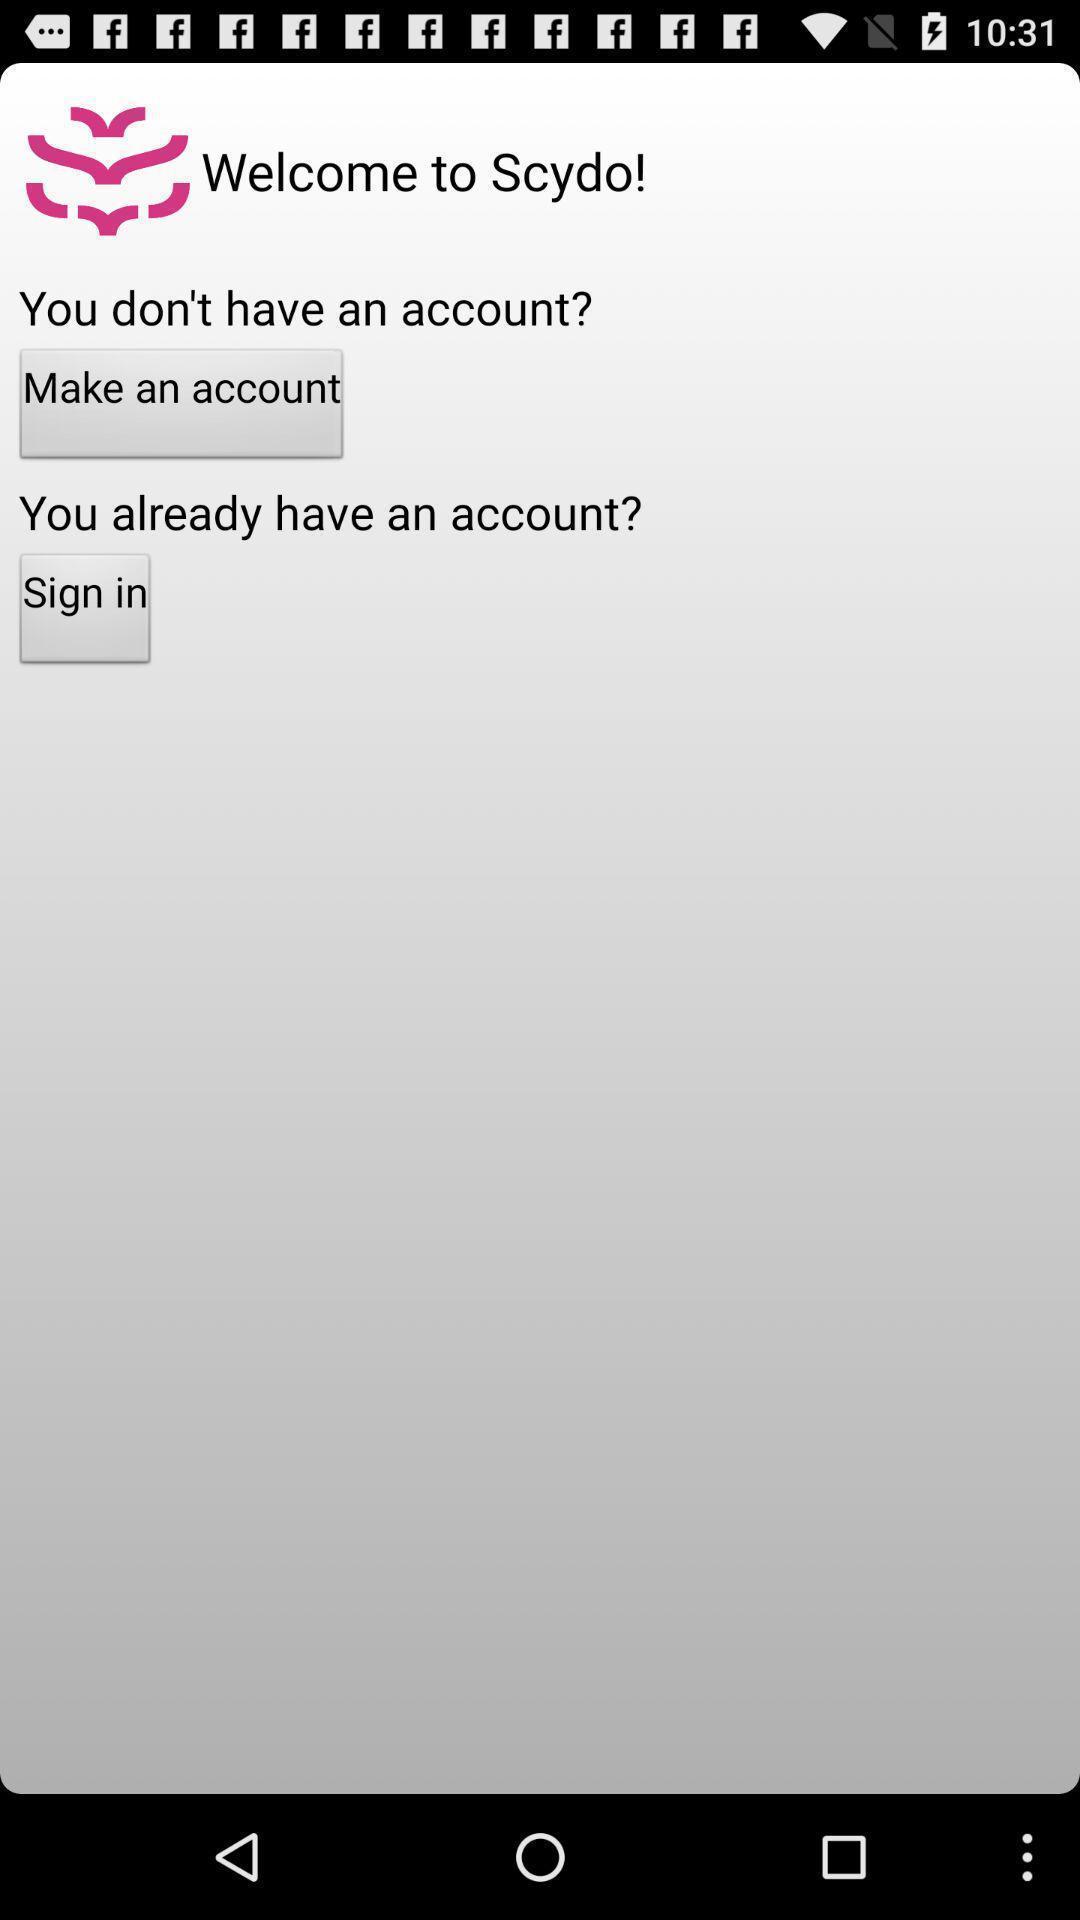What details can you identify in this image? Welcome page with sign in option. 